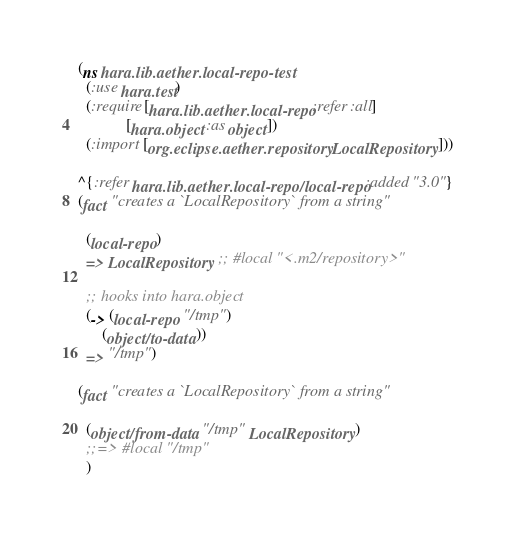<code> <loc_0><loc_0><loc_500><loc_500><_Clojure_>(ns hara.lib.aether.local-repo-test
  (:use hara.test)
  (:require [hara.lib.aether.local-repo :refer :all]
            [hara.object :as object])
  (:import [org.eclipse.aether.repository LocalRepository]))

^{:refer hara.lib.aether.local-repo/local-repo :added "3.0"}
(fact "creates a `LocalRepository` from a string"

  (local-repo)
  => LocalRepository ;; #local "<.m2/repository>"

  ;; hooks into hara.object
  (-> (local-repo "/tmp")
      (object/to-data))
  => "/tmp")

(fact "creates a `LocalRepository` from a string"

  (object/from-data "/tmp" LocalRepository)
  ;;=> #local "/tmp"
  )</code> 